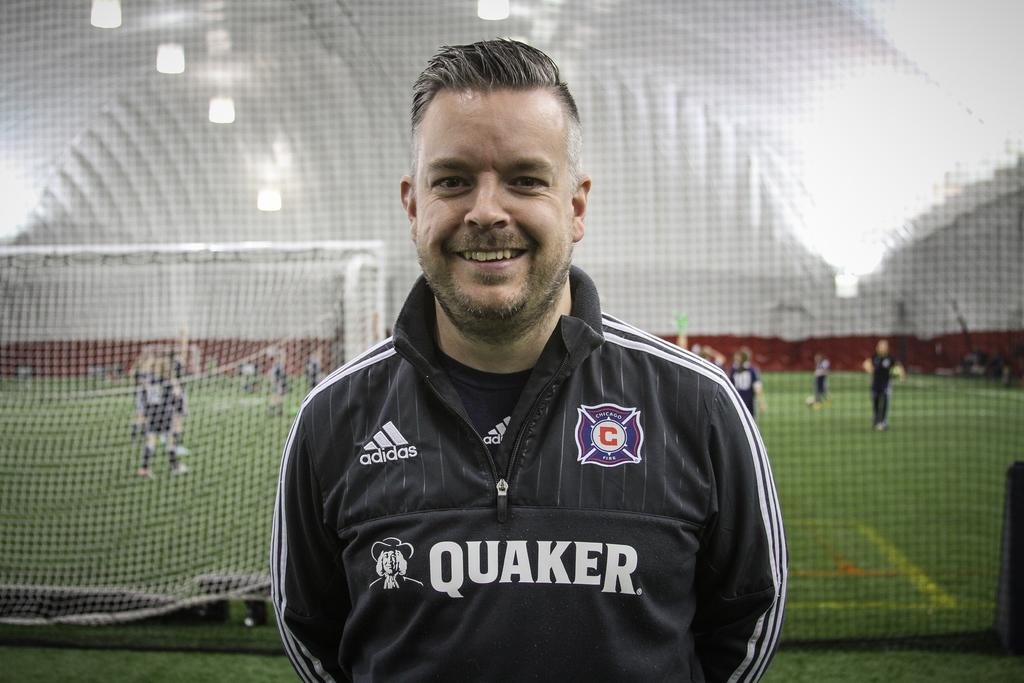<image>
Render a clear and concise summary of the photo. A man standing on a sports field with a black and white jersey that says Quaker on the front. 